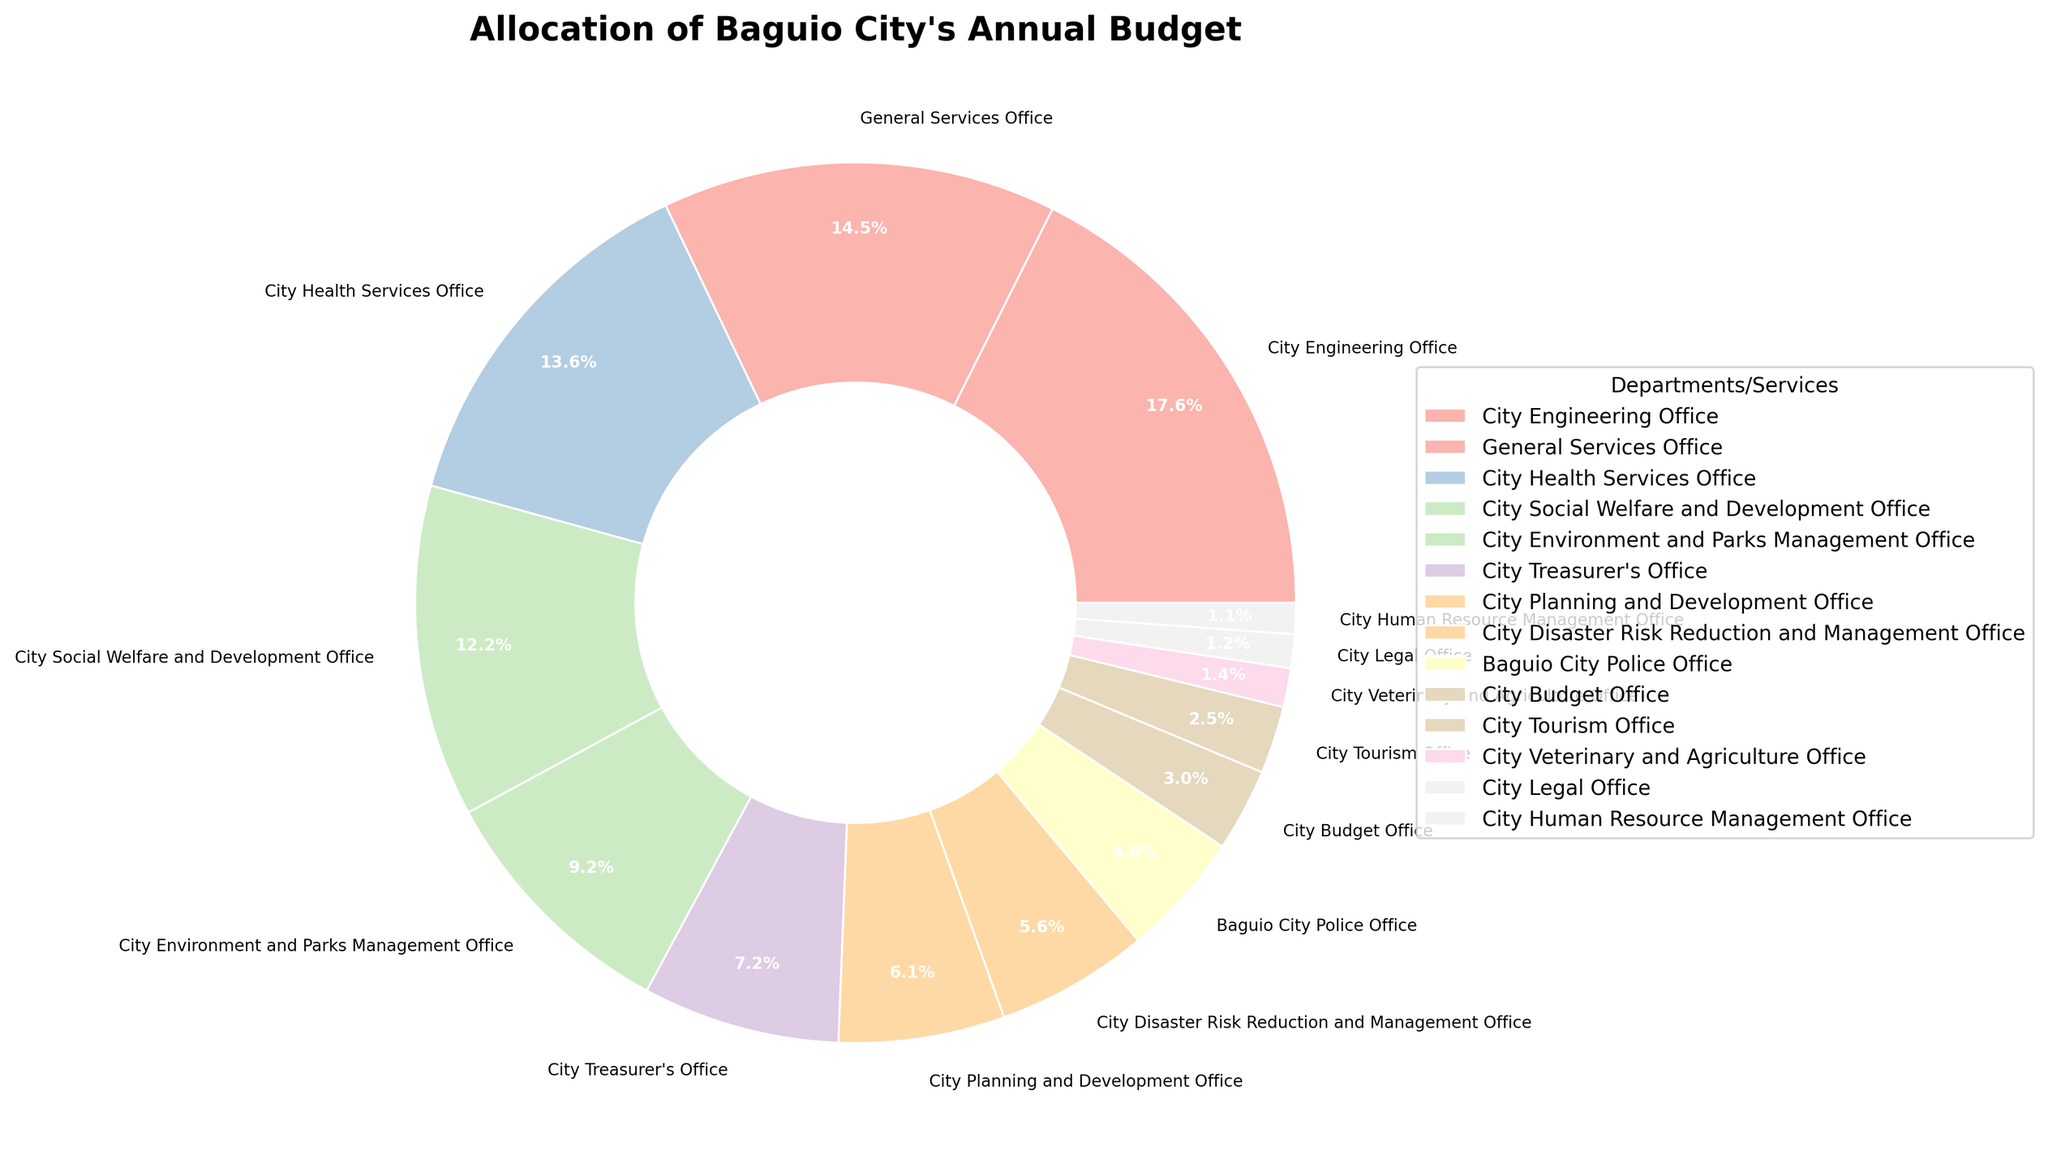What's the percentage allocation for the City Health Services Office? Look at the slice labeled "City Health Services Office" on the pie chart and read the percentage value next to it.
Answer: 14.3% Which department/service gets the second-largest allocation? Compare the size of the slices in the pie chart. The "City Engineering Office" has the largest allocation, so look for the next largest slice, which is the "General Services Office".
Answer: General Services Office What is the combined budget allocation percentage for City Tourism Office and City Veterinary and Agriculture Office? Add the percentages of "City Tourism Office" (2.6%) and "City Veterinary and Agriculture Office" (1.5%) from the pie chart. 2.6 + 1.5 = 4.1
Answer: 4.1% Is the budget for the Baguio City Police Office more than the City Disaster Risk Reduction and Management Office? Compare the percentages of the "Baguio City Police Office" (4.8%) and the "City Disaster Risk Reduction and Management Office" (5.9%) on the pie chart. 4.8 < 5.9
Answer: No If the City Treasurer's Office and City Planning and Development Office were to combine their budgets, what percentage of the total budget would they receive? Add the percentages of the "City Treasurer's Office" (7.6%) and the "City Planning and Development Office" (6.4%) from the pie chart. 7.6 + 6.4 = 14.0
Answer: 14.0% What is the difference in budget allocation between the largest slice and the smallest slice? Identify the largest slice (City Engineering Office, 18.5%) and the smallest slice (City Human Resource Management Office, 1.2%). Subtract the smallest percentage from the largest percentage. 18.5 - 1.2 = 17.3
Answer: 17.3% Which departments/services receive less than 5% of the budget? Look at the slices with percentages less than 5%: "Baguio City Police Office" (4.8%), "City Budget Office" (3.2%), "City Tourism Office" (2.6%), "City Veterinary and Agriculture Office" (1.5%), "City Legal Office" (1.3%), and "City Human Resource Management Office" (1.2%).
Answer: Baguio City Police Office, City Budget Office, City Tourism Office, City Veterinary and Agriculture Office, City Legal Office, City Human Resource Management Office How much greater is the budget for the City Environment and Parks Management Office compared to the City Planning and Development Office? Look at the percentages: "City Environment and Parks Management Office" (9.7%) and "City Planning and Development Office" (6.4%). Subtract the smaller percentage from the larger percentage. 9.7 - 6.4 = 3.3
Answer: 3.3% Which department has a budget almost equal to that of the City Treasurer's Office? Compare the department percentages to that of "City Treasurer's Office" (7.6%). "City Planning and Development Office" is close with 6.4%, but not almost equal. No other department matches closely, hence no direct match can be suggested.
Answer: None What is the average percentage allocated to the City Planning and Development Office, City Disaster Risk Reduction and Management Office, and City Veterinary and Agriculture Office? Sum their percentages (6.4 + 5.9 + 1.5) and divide by 3. (6.4 + 5.9 + 1.5) / 3 = 4.6
Answer: 4.6 